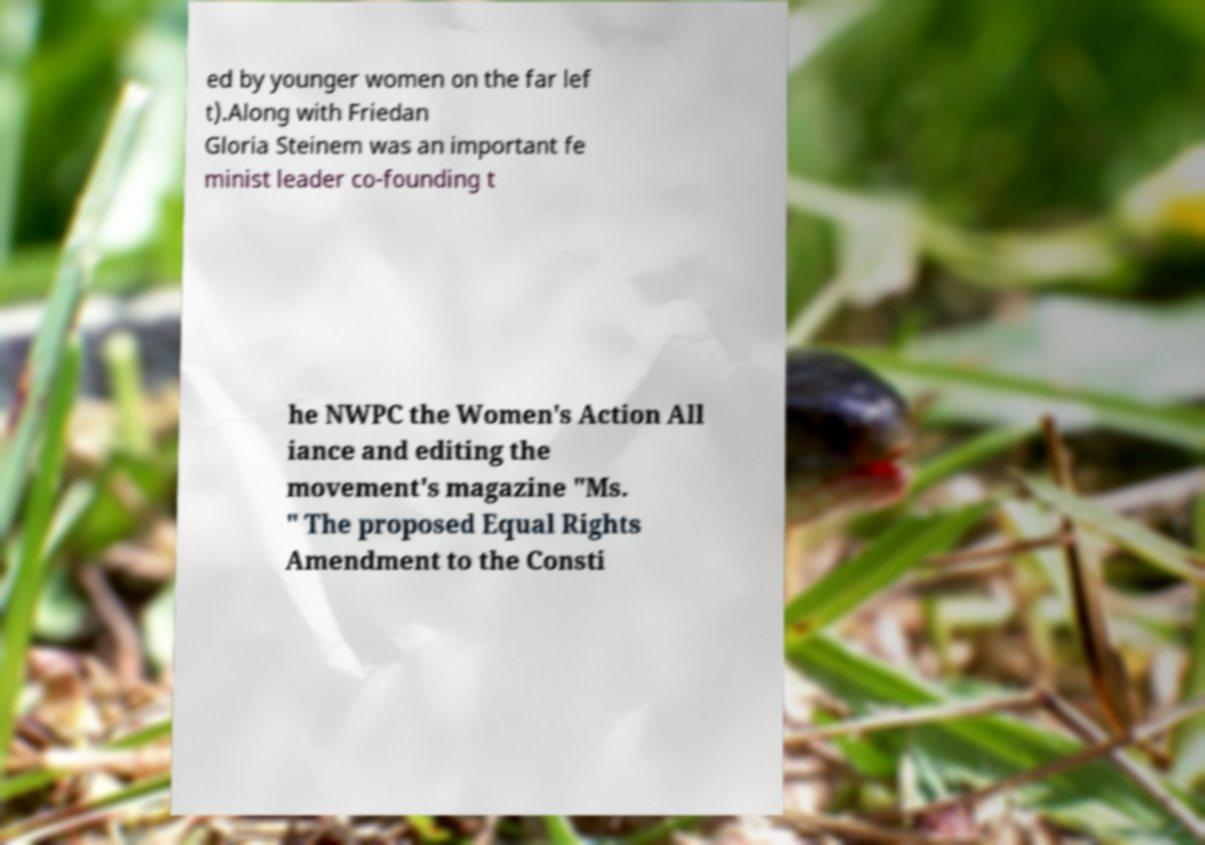Can you read and provide the text displayed in the image?This photo seems to have some interesting text. Can you extract and type it out for me? ed by younger women on the far lef t).Along with Friedan Gloria Steinem was an important fe minist leader co-founding t he NWPC the Women's Action All iance and editing the movement's magazine "Ms. " The proposed Equal Rights Amendment to the Consti 